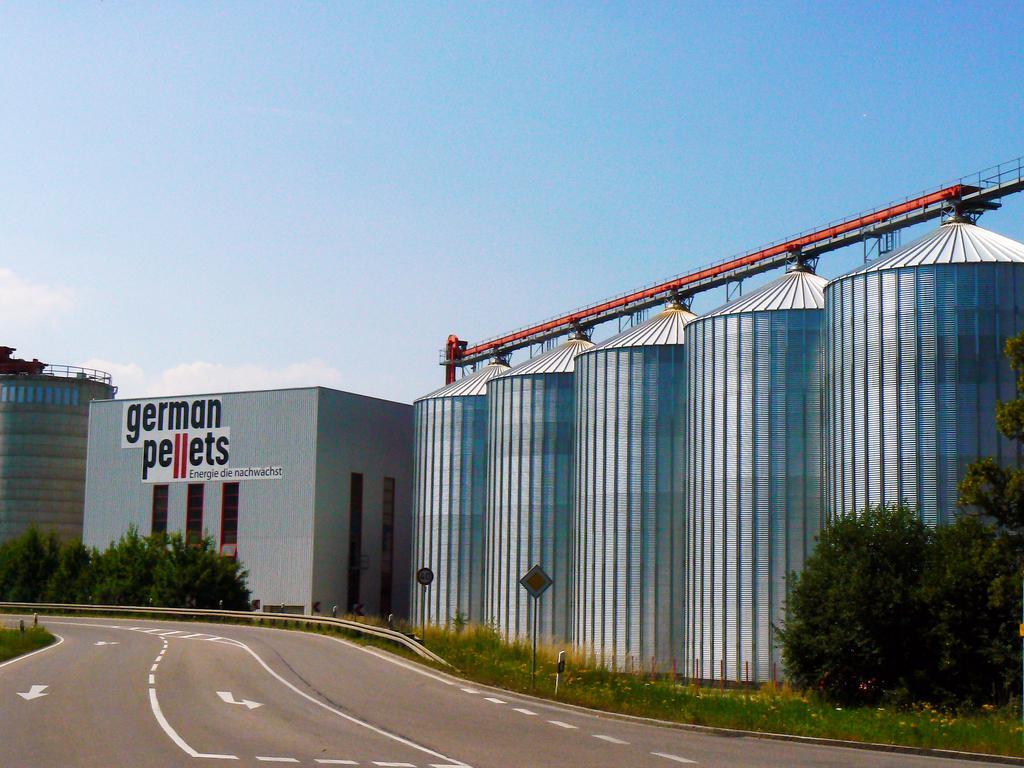In one or two sentences, can you explain what this image depicts? This picture shows buildings and we see trees and couple of sign boards and we see metal barrels and a blue cloudy sky. 